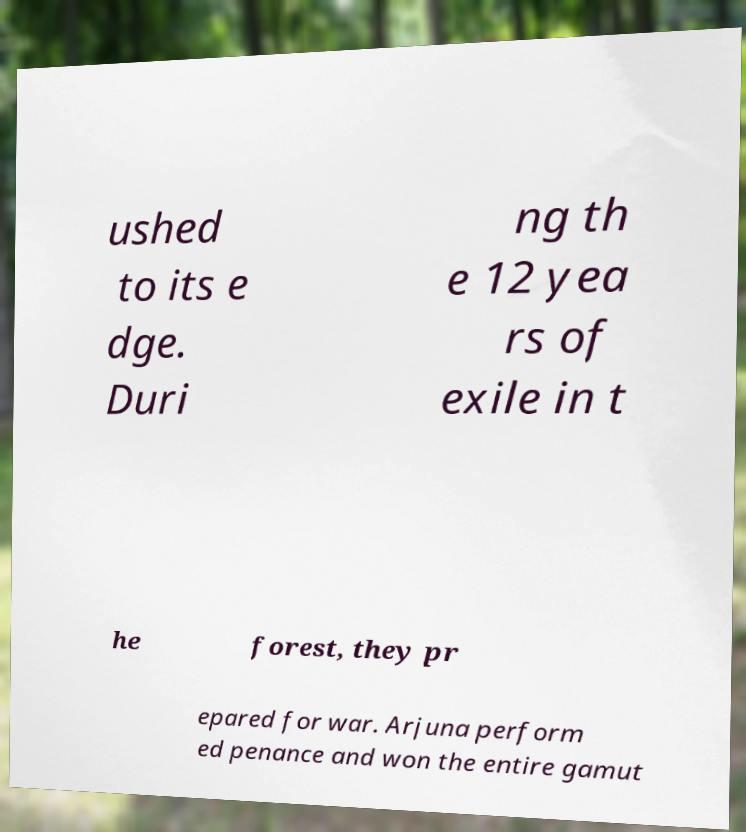Please identify and transcribe the text found in this image. ushed to its e dge. Duri ng th e 12 yea rs of exile in t he forest, they pr epared for war. Arjuna perform ed penance and won the entire gamut 